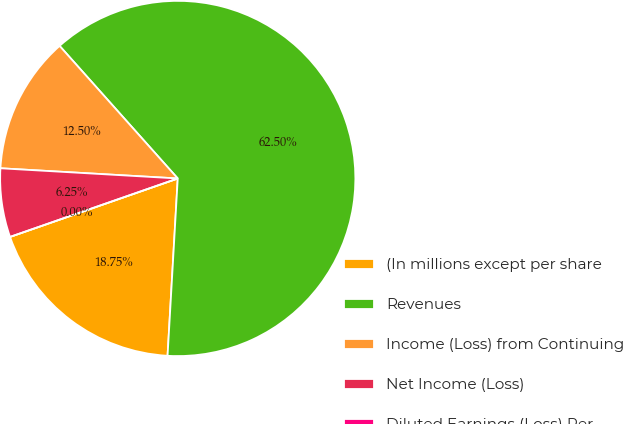Convert chart to OTSL. <chart><loc_0><loc_0><loc_500><loc_500><pie_chart><fcel>(In millions except per share<fcel>Revenues<fcel>Income (Loss) from Continuing<fcel>Net Income (Loss)<fcel>Diluted Earnings (Loss) Per<nl><fcel>18.75%<fcel>62.5%<fcel>12.5%<fcel>6.25%<fcel>0.0%<nl></chart> 